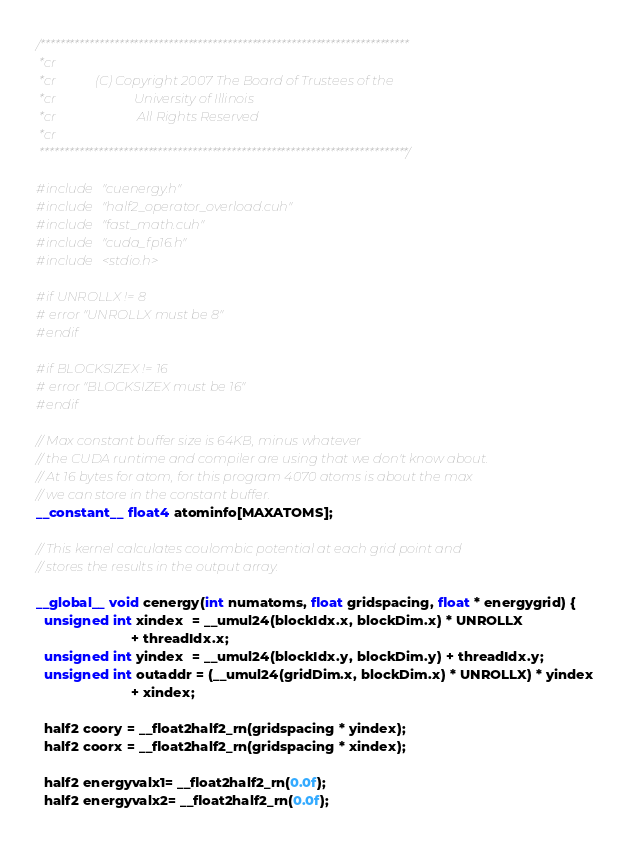Convert code to text. <code><loc_0><loc_0><loc_500><loc_500><_Cuda_>/***************************************************************************
 *cr
 *cr            (C) Copyright 2007 The Board of Trustees of the
 *cr                        University of Illinois
 *cr                         All Rights Reserved
 *cr
 ***************************************************************************/

#include "cuenergy.h"
#include "half2_operator_overload.cuh"
#include "fast_math.cuh"
#include "cuda_fp16.h"
#include <stdio.h>

#if UNROLLX != 8
# error "UNROLLX must be 8"
#endif

#if BLOCKSIZEX != 16
# error "BLOCKSIZEX must be 16"
#endif

// Max constant buffer size is 64KB, minus whatever
// the CUDA runtime and compiler are using that we don't know about.
// At 16 bytes for atom, for this program 4070 atoms is about the max
// we can store in the constant buffer.
__constant__ float4 atominfo[MAXATOMS];

// This kernel calculates coulombic potential at each grid point and
// stores the results in the output array.

__global__ void cenergy(int numatoms, float gridspacing, float * energygrid) {
  unsigned int xindex  = __umul24(blockIdx.x, blockDim.x) * UNROLLX
                         + threadIdx.x;
  unsigned int yindex  = __umul24(blockIdx.y, blockDim.y) + threadIdx.y;
  unsigned int outaddr = (__umul24(gridDim.x, blockDim.x) * UNROLLX) * yindex
                         + xindex;

  half2 coory = __float2half2_rn(gridspacing * yindex);
  half2 coorx = __float2half2_rn(gridspacing * xindex);

  half2 energyvalx1= __float2half2_rn(0.0f);
  half2 energyvalx2= __float2half2_rn(0.0f);</code> 